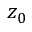Convert formula to latex. <formula><loc_0><loc_0><loc_500><loc_500>z _ { 0 }</formula> 